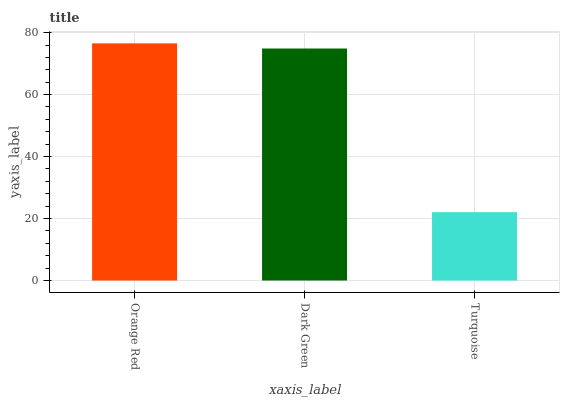Is Dark Green the minimum?
Answer yes or no. No. Is Dark Green the maximum?
Answer yes or no. No. Is Orange Red greater than Dark Green?
Answer yes or no. Yes. Is Dark Green less than Orange Red?
Answer yes or no. Yes. Is Dark Green greater than Orange Red?
Answer yes or no. No. Is Orange Red less than Dark Green?
Answer yes or no. No. Is Dark Green the high median?
Answer yes or no. Yes. Is Dark Green the low median?
Answer yes or no. Yes. Is Orange Red the high median?
Answer yes or no. No. Is Orange Red the low median?
Answer yes or no. No. 